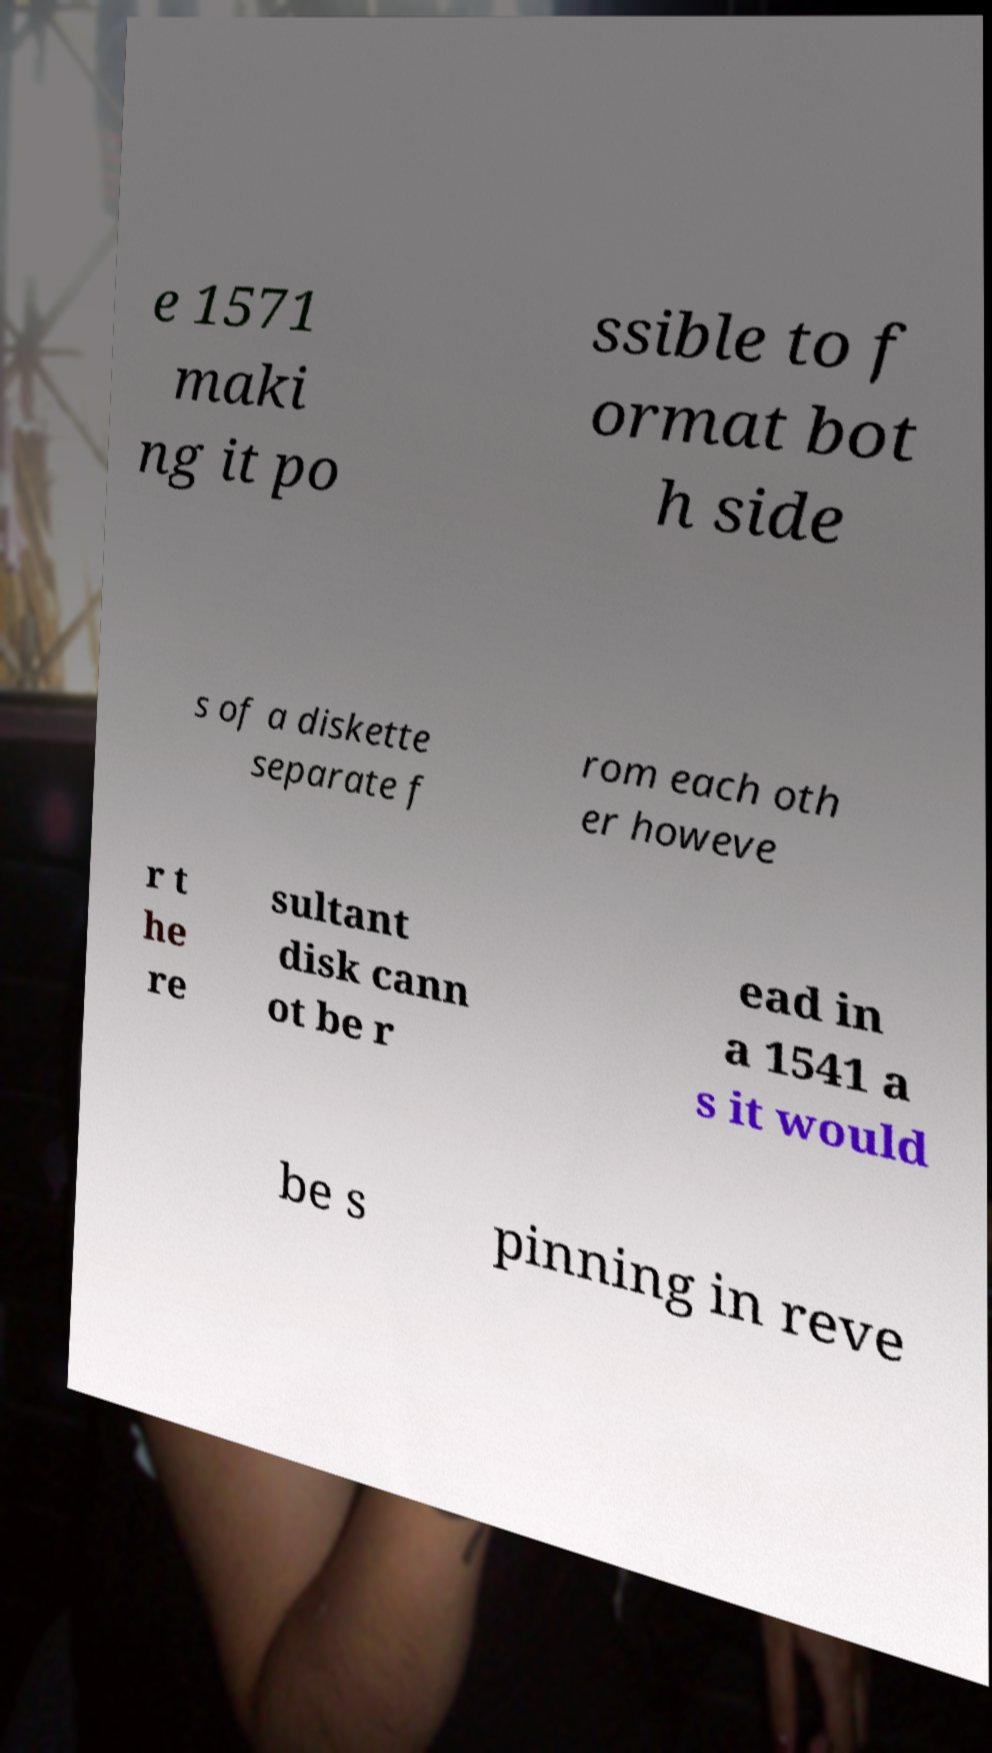Can you read and provide the text displayed in the image?This photo seems to have some interesting text. Can you extract and type it out for me? e 1571 maki ng it po ssible to f ormat bot h side s of a diskette separate f rom each oth er howeve r t he re sultant disk cann ot be r ead in a 1541 a s it would be s pinning in reve 